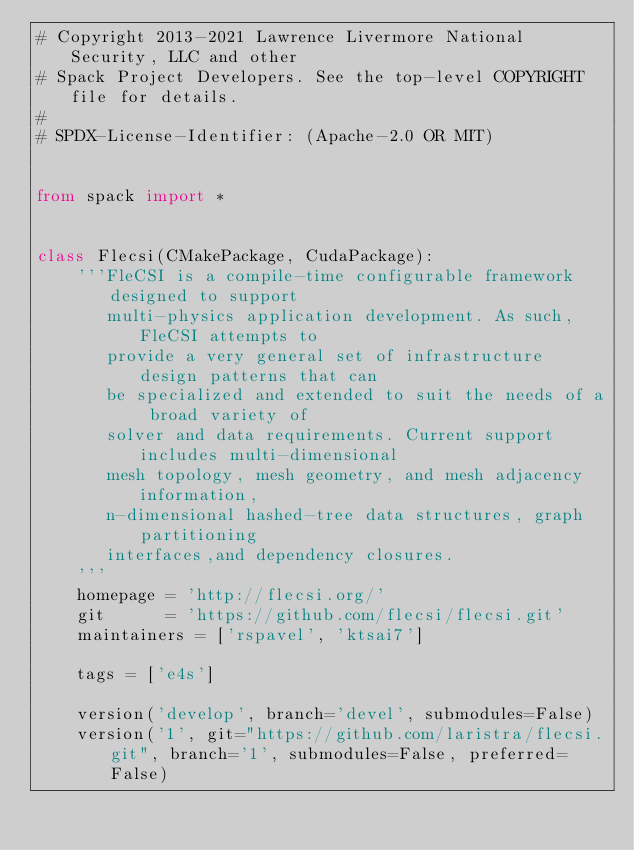Convert code to text. <code><loc_0><loc_0><loc_500><loc_500><_Python_># Copyright 2013-2021 Lawrence Livermore National Security, LLC and other
# Spack Project Developers. See the top-level COPYRIGHT file for details.
#
# SPDX-License-Identifier: (Apache-2.0 OR MIT)


from spack import *


class Flecsi(CMakePackage, CudaPackage):
    '''FleCSI is a compile-time configurable framework designed to support
       multi-physics application development. As such, FleCSI attempts to
       provide a very general set of infrastructure design patterns that can
       be specialized and extended to suit the needs of a broad variety of
       solver and data requirements. Current support includes multi-dimensional
       mesh topology, mesh geometry, and mesh adjacency information,
       n-dimensional hashed-tree data structures, graph partitioning
       interfaces,and dependency closures.
    '''
    homepage = 'http://flecsi.org/'
    git      = 'https://github.com/flecsi/flecsi.git'
    maintainers = ['rspavel', 'ktsai7']

    tags = ['e4s']

    version('develop', branch='devel', submodules=False)
    version('1', git="https://github.com/laristra/flecsi.git", branch='1', submodules=False, preferred=False)</code> 